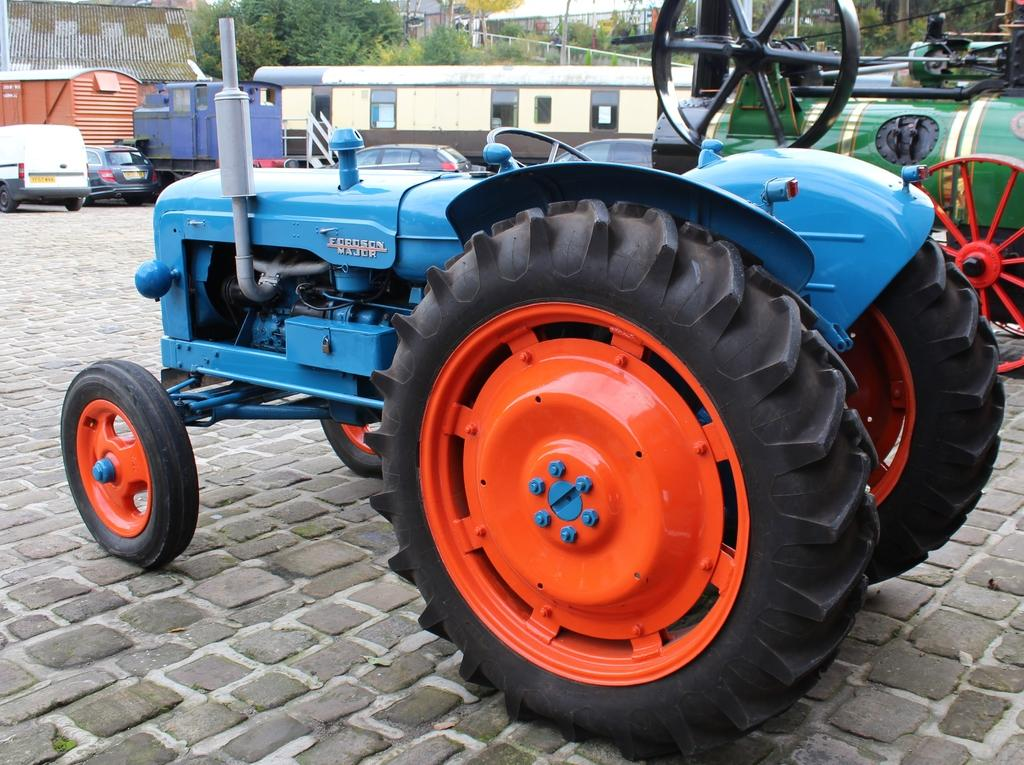What types of objects are present in the image? There are vehicles in the image. Can you describe the color of one of the vehicles? One vehicle is blue and orange in color. What can be seen in the background of the image? There are buildings and trees with green color in the background of the image. What else is visible in the image? There are poles visible in the image. Are there any tents visible in the image? There are no tents present in the image. Can you describe the motion of the vehicles in the image? The vehicles are stationary in the image, so there is no motion to describe. 